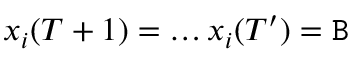<formula> <loc_0><loc_0><loc_500><loc_500>x _ { i } ( T + 1 ) = \dots x _ { i } ( T ^ { \prime } ) = B</formula> 